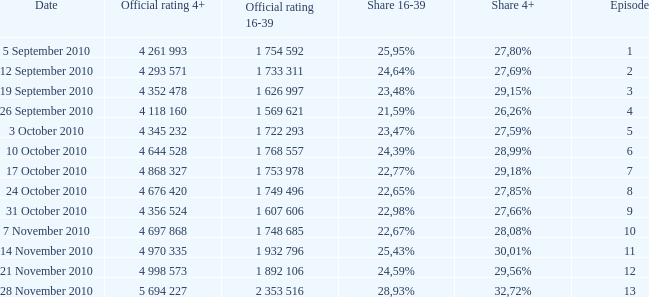What is the official rating 16-39 for the episode with  a 16-39 share of 22,77%? 1 753 978. 